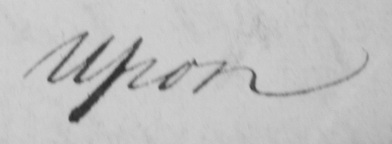Please provide the text content of this handwritten line. Upon 